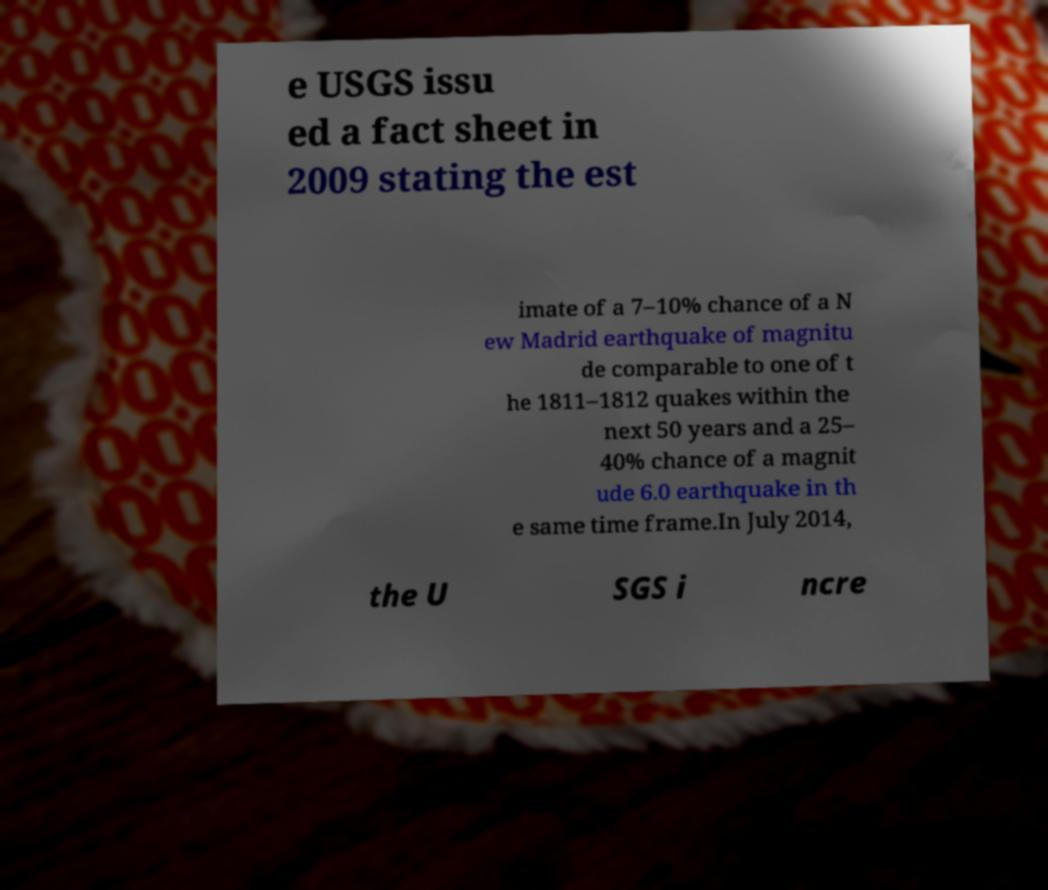What messages or text are displayed in this image? I need them in a readable, typed format. e USGS issu ed a fact sheet in 2009 stating the est imate of a 7–10% chance of a N ew Madrid earthquake of magnitu de comparable to one of t he 1811–1812 quakes within the next 50 years and a 25– 40% chance of a magnit ude 6.0 earthquake in th e same time frame.In July 2014, the U SGS i ncre 